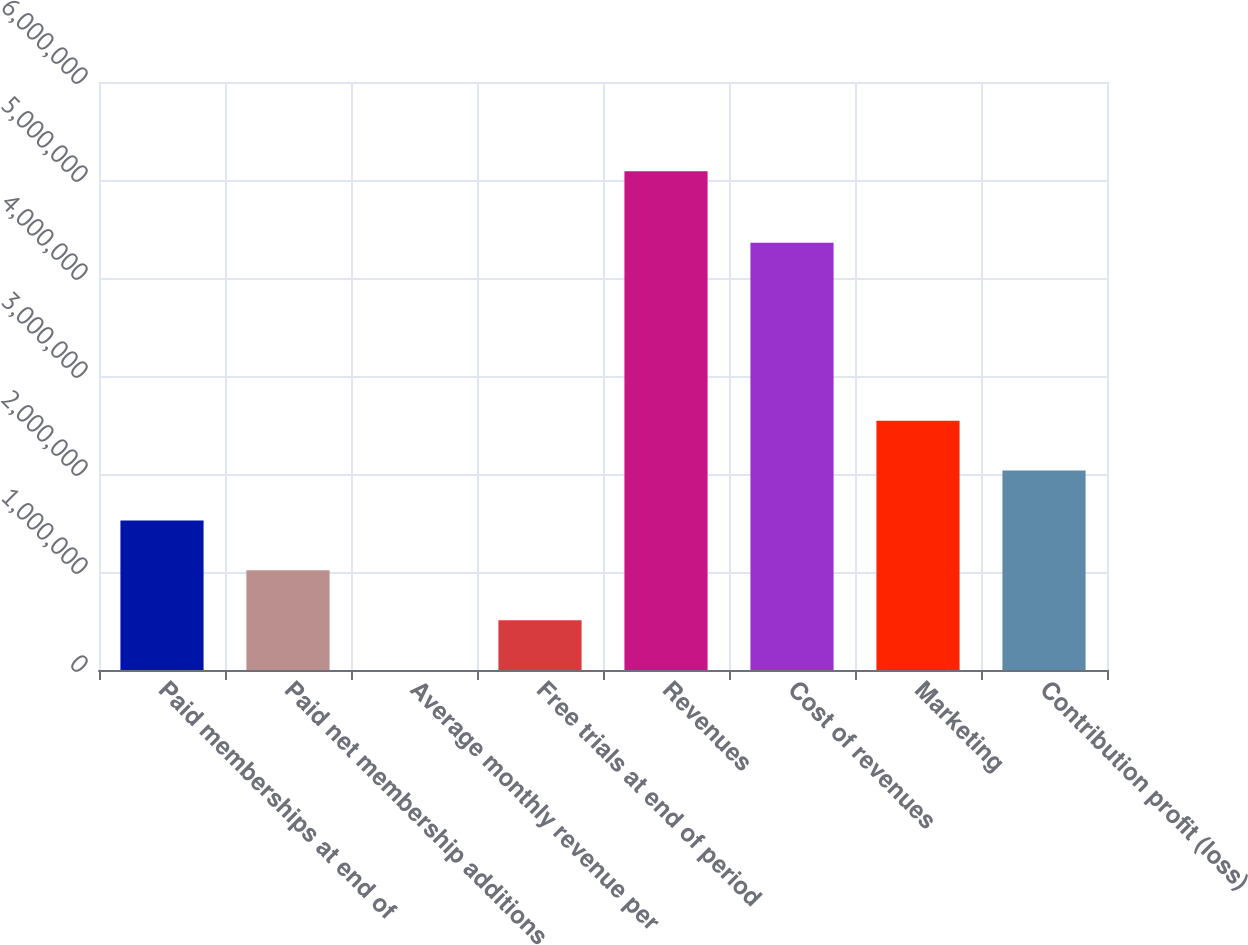Convert chart to OTSL. <chart><loc_0><loc_0><loc_500><loc_500><bar_chart><fcel>Paid memberships at end of<fcel>Paid net membership additions<fcel>Average monthly revenue per<fcel>Free trials at end of period<fcel>Revenues<fcel>Cost of revenues<fcel>Marketing<fcel>Contribution profit (loss)<nl><fcel>1.52676e+06<fcel>1.01785e+06<fcel>8.66<fcel>508927<fcel>5.08919e+06<fcel>4.35962e+06<fcel>2.5446e+06<fcel>2.03568e+06<nl></chart> 